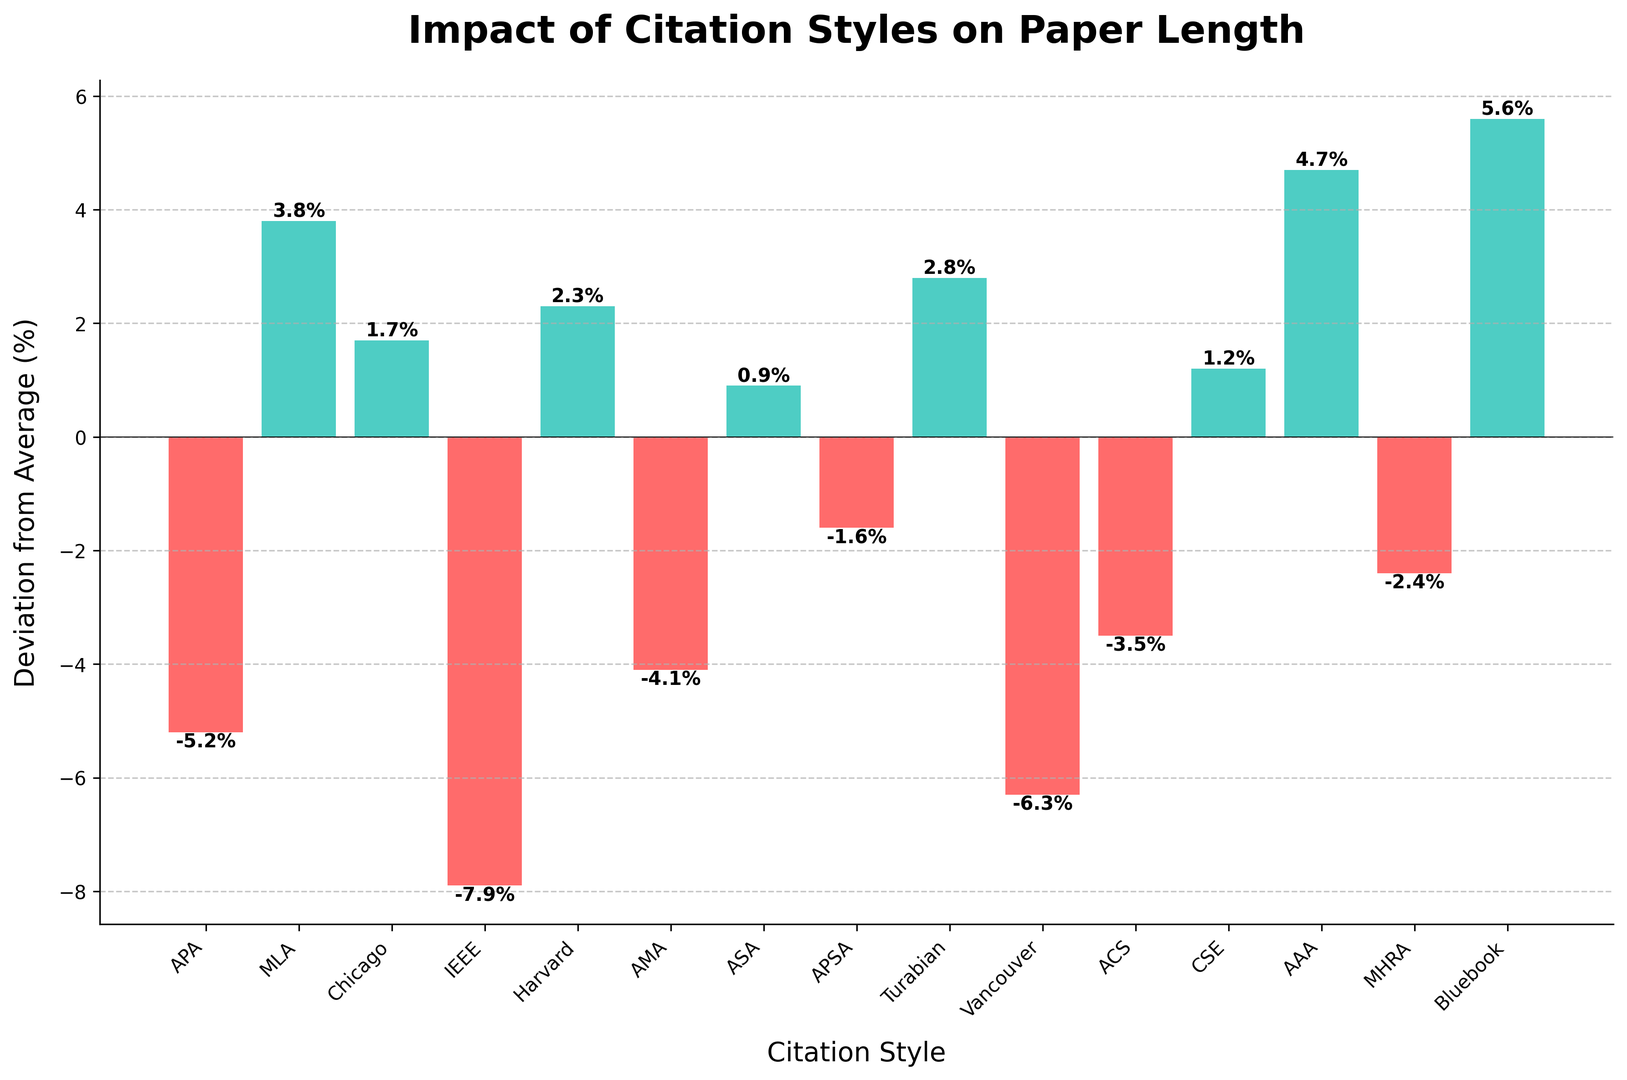Which citation style has the highest positive deviation from the average paper length? The citation style with the highest positive deviation can be determined by looking for the tallest green bar. The Bluebook citation style has the highest positive deviation at 5.6%.
Answer: Bluebook Which citation style results in the shortest average paper length? The citation style with the shortest average paper length has the largest negative deviation. IEEE has the largest negative deviation at -7.9%.
Answer: IEEE What is the combined deviation for Harvard and Chicago citation styles? To find the combined deviation, add the deviations of Harvard (2.3%) and Chicago (1.7%). The result is 2.3 + 1.7 = 4.0%.
Answer: 4.0% Which citation styles have a negative deviation from the average paper length? The citation styles with a negative deviation can be determined by identifying the bars in red. They are APA (-5.2%), IEEE (-7.9%), AMA (-4.1%), APSA (-1.6%), Vancouver (-6.3%), ACS (-3.5%), and MHRA (-2.4%).
Answer: APA, IEEE, AMA, APSA, Vancouver, ACS, MHRA How much longer, in percentage points, is the paper length for Bluebook style compared to IEEE style? Bluebook has a deviation of 5.6% and IEEE has a deviation of -7.9%. The difference in paper length is 5.6 - (-7.9) = 5.6 + 7.9 = 13.5 percentage points.
Answer: 13.5 What is the average deviation for all citation styles? Sum all the deviations and divide by the number of citation styles. The sum of deviations is -5.2 + 3.8 + 1.7 - 7.9 + 2.3 - 4.1 + 0.9 - 1.6 + 2.8 - 6.3 - 3.5 + 1.2 + 4.7 - 2.4 + 5.6 = -7.9. Divide by 15 styles: -7.9 / 15 ≈ -0.53%.
Answer: -0.53% Which citation styles have deviations closest to zero? The citation styles with deviations closest to zero would be the bars closest to the horizontal line at 0. ASA has a deviation of 0.9% and CSE has a deviation of 1.2%.
Answer: ASA, CSE How many citation styles have a deviation greater than 3%? Identify the bars with heights greater than 3%. MLA (3.8%), Bluebook (5.6%), and AAA (4.7%) have deviations greater than 3%. So there are 3 styles in total.
Answer: 3 